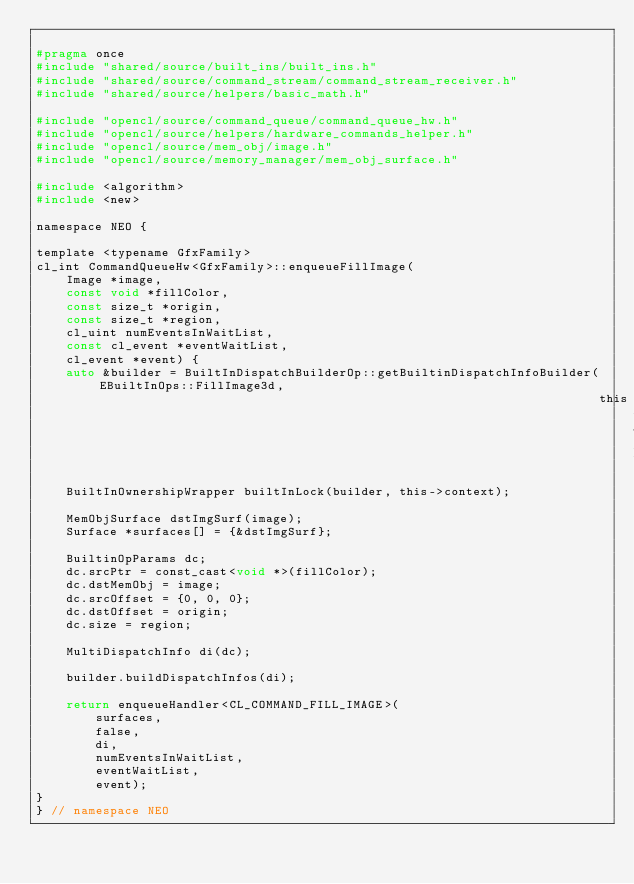<code> <loc_0><loc_0><loc_500><loc_500><_C_>
#pragma once
#include "shared/source/built_ins/built_ins.h"
#include "shared/source/command_stream/command_stream_receiver.h"
#include "shared/source/helpers/basic_math.h"

#include "opencl/source/command_queue/command_queue_hw.h"
#include "opencl/source/helpers/hardware_commands_helper.h"
#include "opencl/source/mem_obj/image.h"
#include "opencl/source/memory_manager/mem_obj_surface.h"

#include <algorithm>
#include <new>

namespace NEO {

template <typename GfxFamily>
cl_int CommandQueueHw<GfxFamily>::enqueueFillImage(
    Image *image,
    const void *fillColor,
    const size_t *origin,
    const size_t *region,
    cl_uint numEventsInWaitList,
    const cl_event *eventWaitList,
    cl_event *event) {
    auto &builder = BuiltInDispatchBuilderOp::getBuiltinDispatchInfoBuilder(EBuiltInOps::FillImage3d,
                                                                            this->getClDevice());
    BuiltInOwnershipWrapper builtInLock(builder, this->context);

    MemObjSurface dstImgSurf(image);
    Surface *surfaces[] = {&dstImgSurf};

    BuiltinOpParams dc;
    dc.srcPtr = const_cast<void *>(fillColor);
    dc.dstMemObj = image;
    dc.srcOffset = {0, 0, 0};
    dc.dstOffset = origin;
    dc.size = region;

    MultiDispatchInfo di(dc);

    builder.buildDispatchInfos(di);

    return enqueueHandler<CL_COMMAND_FILL_IMAGE>(
        surfaces,
        false,
        di,
        numEventsInWaitList,
        eventWaitList,
        event);
}
} // namespace NEO
</code> 